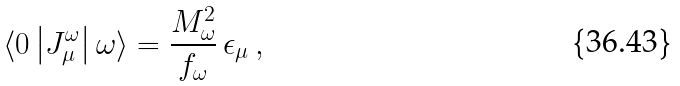Convert formula to latex. <formula><loc_0><loc_0><loc_500><loc_500>\langle 0 \left | J _ { \mu } ^ { \omega } \right | \omega \rangle = \frac { M _ { \omega } ^ { 2 } } { f _ { \omega } } \, \epsilon _ { \mu } \, ,</formula> 